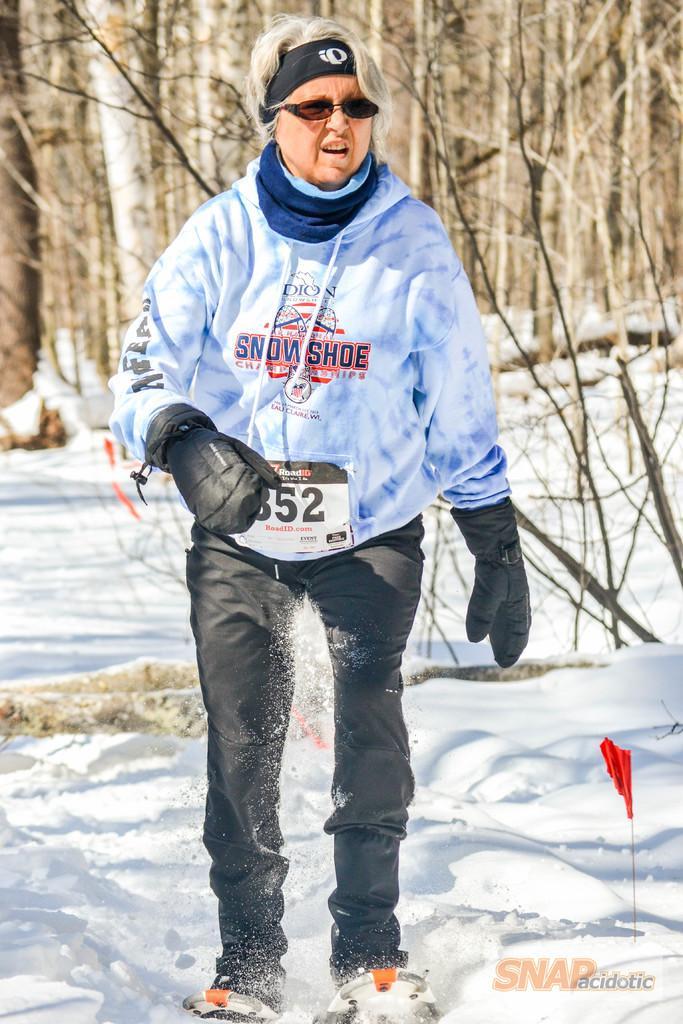How would you summarize this image in a sentence or two? Here we see a woman standing in the snow with gloves to both her hands and spectacles on her face and a band to her head and with a snow shoe. 